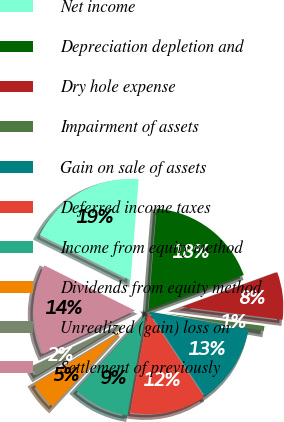Convert chart. <chart><loc_0><loc_0><loc_500><loc_500><pie_chart><fcel>Net income<fcel>Depreciation depletion and<fcel>Dry hole expense<fcel>Impairment of assets<fcel>Gain on sale of assets<fcel>Deferred income taxes<fcel>Income from equity method<fcel>Dividends from equity method<fcel>Unrealized (gain) loss on<fcel>Settlement of previously<nl><fcel>18.92%<fcel>18.16%<fcel>7.58%<fcel>0.78%<fcel>12.87%<fcel>12.12%<fcel>9.09%<fcel>4.56%<fcel>1.53%<fcel>14.38%<nl></chart> 